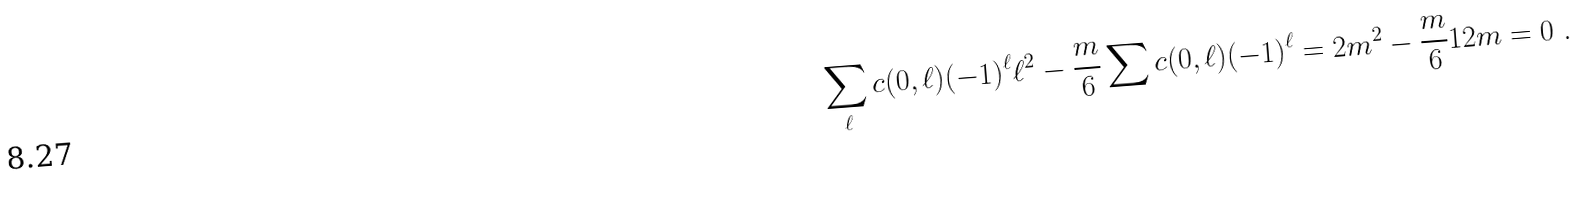<formula> <loc_0><loc_0><loc_500><loc_500>\sum _ { \ell } c ( 0 , \ell ) ( - 1 ) ^ { \ell } \ell ^ { 2 } - \frac { m } { 6 } \sum c ( 0 , \ell ) ( - 1 ) ^ { \ell } = 2 m ^ { 2 } - \frac { m } { 6 } 1 2 m = 0 \ .</formula> 